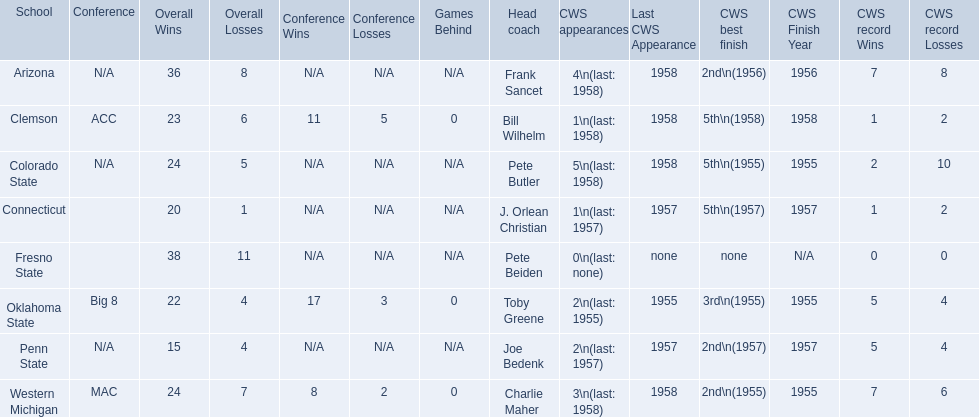Which teams played in the 1959 ncaa university division baseball tournament? Arizona, Clemson, Colorado State, Connecticut, Fresno State, Oklahoma State, Penn State, Western Michigan. Which was the only one to win less than 20 games? Penn State. 